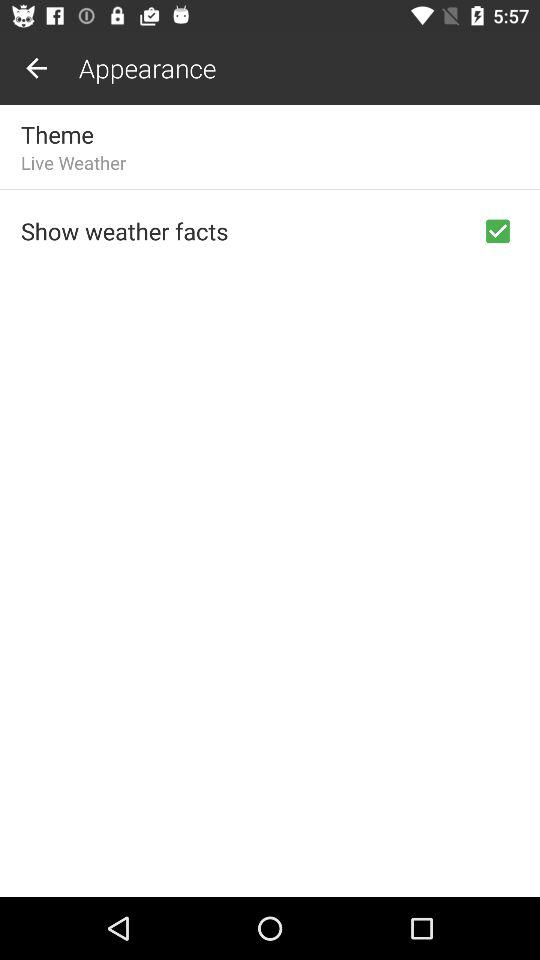Which theme is selected? The selected theme is "Live Weather". 